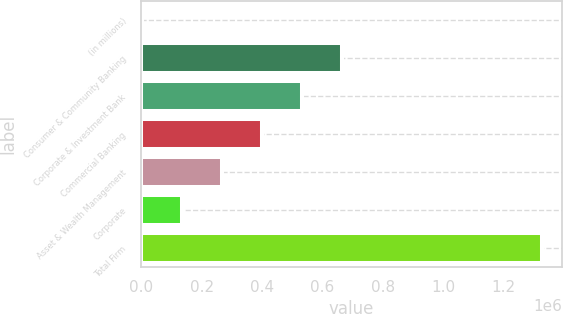Convert chart. <chart><loc_0><loc_0><loc_500><loc_500><bar_chart><fcel>(in millions)<fcel>Consumer & Community Banking<fcel>Corporate & Investment Bank<fcel>Commercial Banking<fcel>Asset & Wealth Management<fcel>Corporate<fcel>Total Firm<nl><fcel>2016<fcel>664992<fcel>532397<fcel>399802<fcel>267206<fcel>134611<fcel>1.32797e+06<nl></chart> 